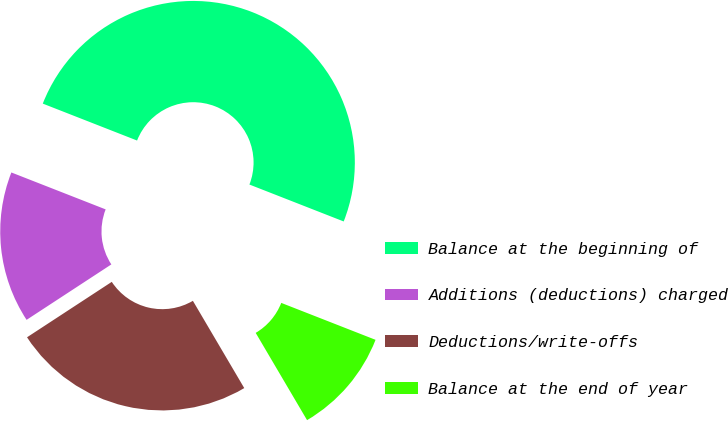<chart> <loc_0><loc_0><loc_500><loc_500><pie_chart><fcel>Balance at the beginning of<fcel>Additions (deductions) charged<fcel>Deductions/write-offs<fcel>Balance at the end of year<nl><fcel>50.0%<fcel>15.16%<fcel>24.25%<fcel>10.59%<nl></chart> 